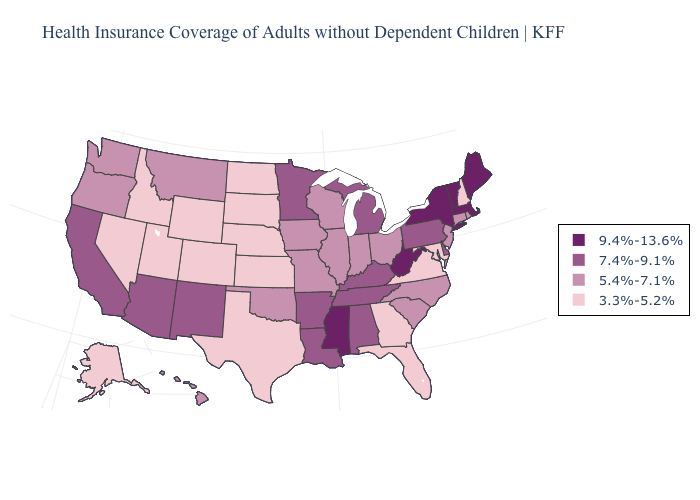What is the highest value in the USA?
Short answer required. 9.4%-13.6%. What is the value of Ohio?
Answer briefly. 5.4%-7.1%. Name the states that have a value in the range 7.4%-9.1%?
Be succinct. Alabama, Arizona, Arkansas, California, Delaware, Kentucky, Louisiana, Michigan, Minnesota, New Mexico, Pennsylvania, Tennessee. Name the states that have a value in the range 9.4%-13.6%?
Short answer required. Maine, Massachusetts, Mississippi, New York, Vermont, West Virginia. Name the states that have a value in the range 5.4%-7.1%?
Keep it brief. Connecticut, Hawaii, Illinois, Indiana, Iowa, Missouri, Montana, New Jersey, North Carolina, Ohio, Oklahoma, Oregon, Rhode Island, South Carolina, Washington, Wisconsin. Does California have the lowest value in the USA?
Be succinct. No. Does Massachusetts have a lower value than New Jersey?
Be succinct. No. What is the value of Oregon?
Concise answer only. 5.4%-7.1%. What is the value of South Dakota?
Quick response, please. 3.3%-5.2%. What is the value of Maine?
Answer briefly. 9.4%-13.6%. Does South Carolina have a lower value than Georgia?
Concise answer only. No. What is the lowest value in the USA?
Quick response, please. 3.3%-5.2%. What is the value of Tennessee?
Write a very short answer. 7.4%-9.1%. Name the states that have a value in the range 9.4%-13.6%?
Concise answer only. Maine, Massachusetts, Mississippi, New York, Vermont, West Virginia. What is the value of North Dakota?
Quick response, please. 3.3%-5.2%. 